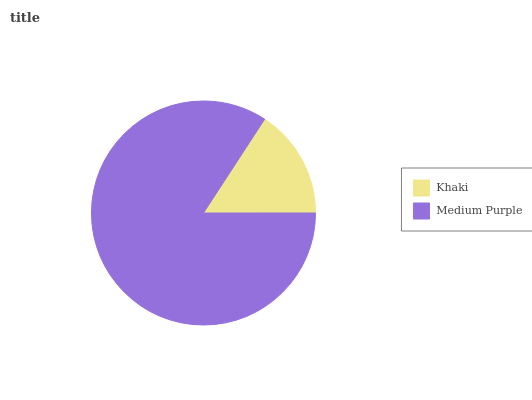Is Khaki the minimum?
Answer yes or no. Yes. Is Medium Purple the maximum?
Answer yes or no. Yes. Is Medium Purple the minimum?
Answer yes or no. No. Is Medium Purple greater than Khaki?
Answer yes or no. Yes. Is Khaki less than Medium Purple?
Answer yes or no. Yes. Is Khaki greater than Medium Purple?
Answer yes or no. No. Is Medium Purple less than Khaki?
Answer yes or no. No. Is Medium Purple the high median?
Answer yes or no. Yes. Is Khaki the low median?
Answer yes or no. Yes. Is Khaki the high median?
Answer yes or no. No. Is Medium Purple the low median?
Answer yes or no. No. 